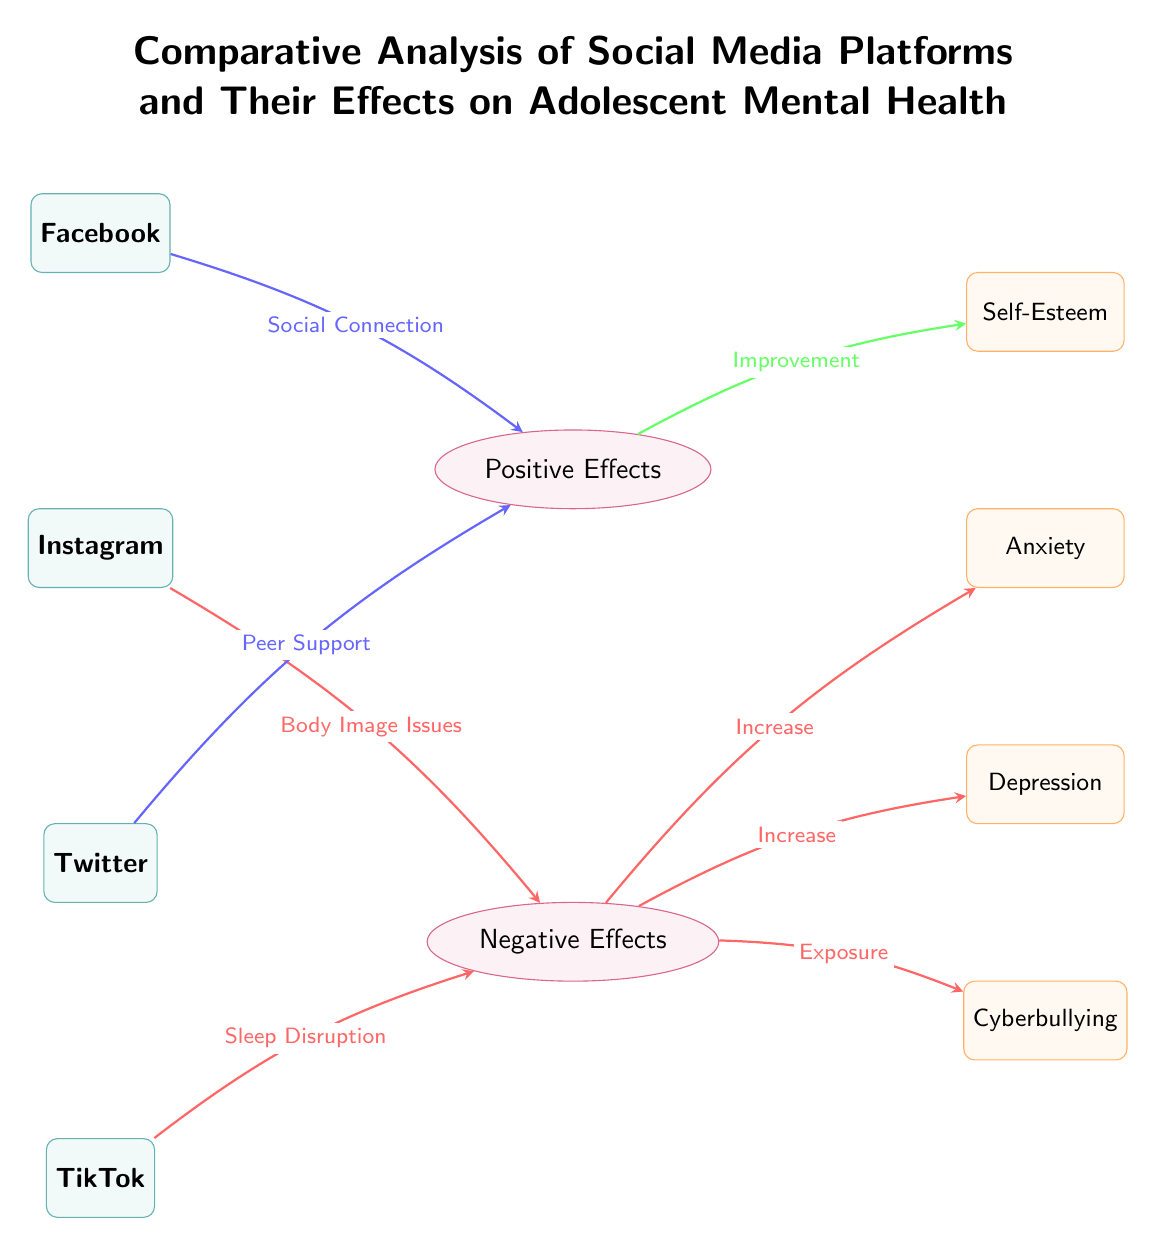What are the four social media platforms listed in the diagram? The diagram explicitly labels four platforms: Facebook, Instagram, Twitter, and TikTok, which are represented at the top left section of the diagram.
Answer: Facebook, Instagram, Twitter, TikTok Which social media platform is associated with "Social Connection"? The connection labeled "Social Connection" points from Facebook to the node "Positive Effects" in the diagram, indicating the relationship.
Answer: Facebook What is one negative effect associated with Instagram? The diagram identifies "Body Image Issues" as the negative effect linked to Instagram, which is indicated by the arrow leading to the negative effects section.
Answer: Body Image Issues How many outcomes are mentioned in the diagram? There are four outcomes listed in the diagram: Self-Esteem, Anxiety, Depression, and Cyberbullying, which are located in the right section of the diagram.
Answer: Four What effect does TikTok have on sleep according to the diagram? The arrow flowing from TikTok to the negative effects node shows "Sleep Disruption" as the effect TikTok has, demonstrating its association with adverse outcomes.
Answer: Sleep Disruption What is the relationship between Positive Effects and Self-Esteem? The diagram illustrates a direct connection where the Positive Effects node points to Self-Esteem, indicating that positive effects lead to improvement in self-esteem.
Answer: Improvement Which platform is linked to "Peer Support"? The arrow from Twitter in the left section of the diagram connects to the Positive Effects node and is labeled as "Peer Support," establishing its association with this positive effect.
Answer: Twitter What do the negative effects lead to regarding Depression? There is an arrow in the diagram showing that negative effects result in an "Increase" in Depression, illustrating the impact of negative experiences on mental health.
Answer: Increase What color represents the platforms in the diagram? The platforms in the diagram are colored teal, as visually indicated by the fill and draw properties of the depicted nodes.
Answer: Teal 